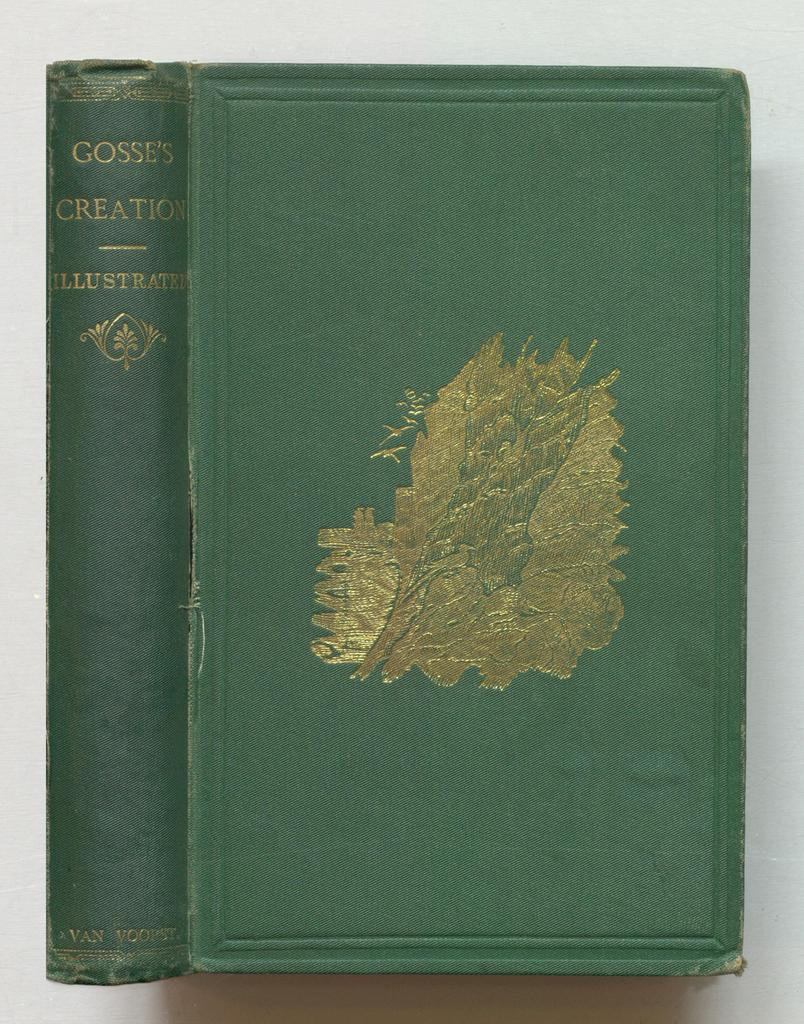<image>
Give a short and clear explanation of the subsequent image. A book titled Gosses Creations is against a white backdrop. 